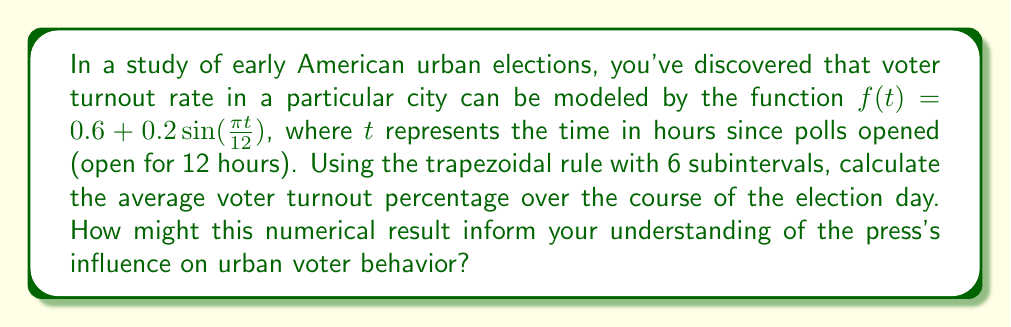Provide a solution to this math problem. To solve this problem, we'll use the trapezoidal rule for numerical integration:

1) The trapezoidal rule formula for n subintervals is:

   $$\int_a^b f(x)dx \approx \frac{b-a}{2n}[f(a) + 2f(x_1) + 2f(x_2) + ... + 2f(x_{n-1}) + f(b)]$$

2) Here, $a=0$, $b=12$, and $n=6$. We need to calculate $f(t)$ at $t = 0, 2, 4, 6, 8, 10, 12$.

3) Calculate function values:
   $f(0) = 0.6 + 0.2\sin(0) = 0.6$
   $f(2) = 0.6 + 0.2\sin(\frac{\pi}{6}) \approx 0.7$
   $f(4) = 0.6 + 0.2\sin(\frac{\pi}{3}) \approx 0.7732$
   $f(6) = 0.6 + 0.2\sin(\frac{\pi}{2}) = 0.8$
   $f(8) = 0.6 + 0.2\sin(\frac{2\pi}{3}) \approx 0.7732$
   $f(10) = 0.6 + 0.2\sin(\frac{5\pi}{6}) \approx 0.7$
   $f(12) = 0.6 + 0.2\sin(\pi) = 0.6$

4) Apply the trapezoidal rule:
   $$\frac{12-0}{2(6)}[0.6 + 2(0.7 + 0.7732 + 0.8 + 0.7732 + 0.7) + 0.6]$$
   $$= 1[0.6 + 2(3.7464) + 0.6] = 1[0.6 + 7.4928 + 0.6] = 8.6928$$

5) This gives us the total area under the curve. To get the average, divide by the interval (12):
   $$\frac{8.6928}{12} \approx 0.7244$$

6) Convert to percentage: 0.7244 * 100% ≈ 72.44%

This result suggests that, on average, about 72.44% of eligible voters participated in the election. As a history professor, you might consider how this turnout compares to other elections and whether factors such as press coverage or urban political dynamics influenced this relatively high average turnout.
Answer: 72.44% 